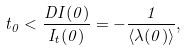<formula> <loc_0><loc_0><loc_500><loc_500>t _ { 0 } < \frac { D I ( 0 ) } { I _ { t } ( 0 ) } = - \frac { 1 } { \langle \lambda ( 0 ) \rangle } ,</formula> 